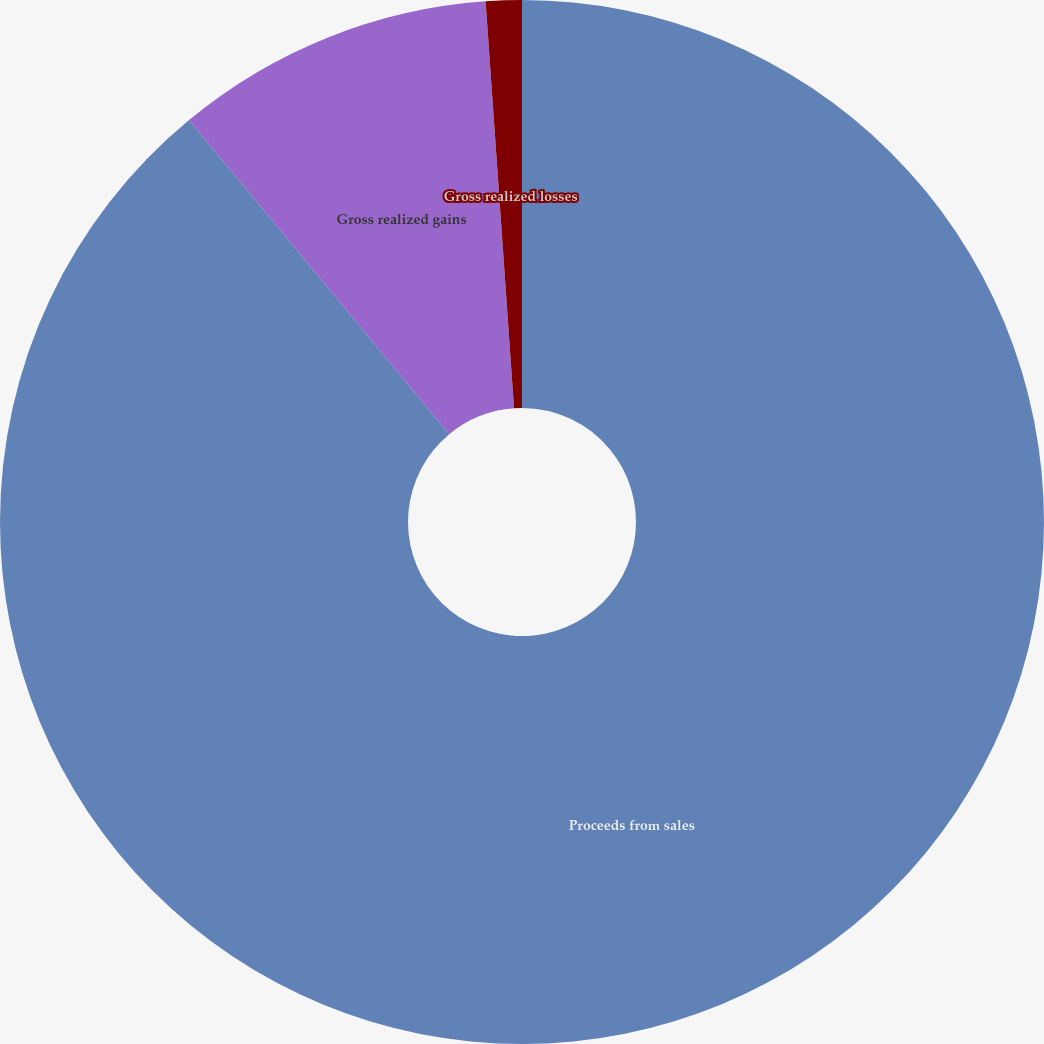Convert chart to OTSL. <chart><loc_0><loc_0><loc_500><loc_500><pie_chart><fcel>Proceeds from sales<fcel>Gross realized gains<fcel>Gross realized losses<nl><fcel>88.99%<fcel>9.9%<fcel>1.11%<nl></chart> 